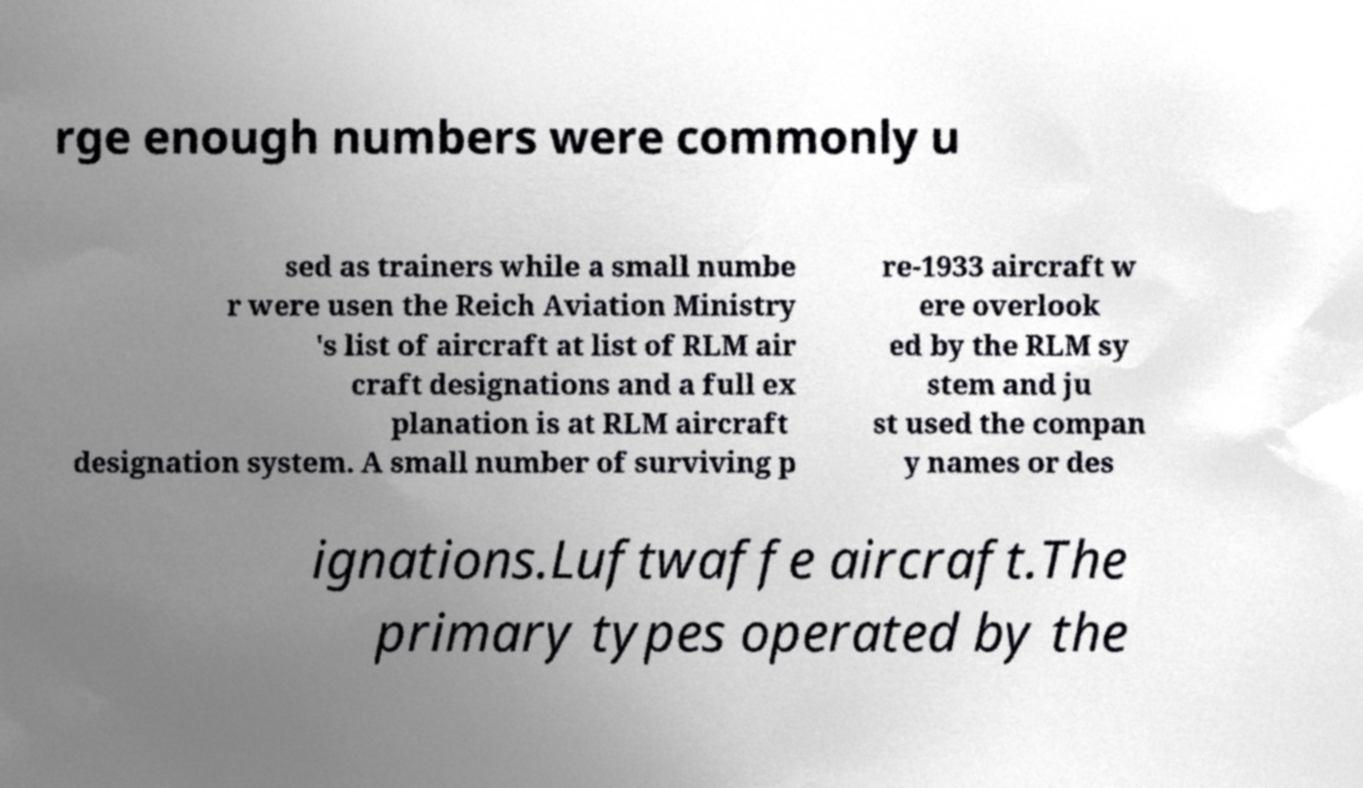Can you accurately transcribe the text from the provided image for me? rge enough numbers were commonly u sed as trainers while a small numbe r were usen the Reich Aviation Ministry 's list of aircraft at list of RLM air craft designations and a full ex planation is at RLM aircraft designation system. A small number of surviving p re-1933 aircraft w ere overlook ed by the RLM sy stem and ju st used the compan y names or des ignations.Luftwaffe aircraft.The primary types operated by the 